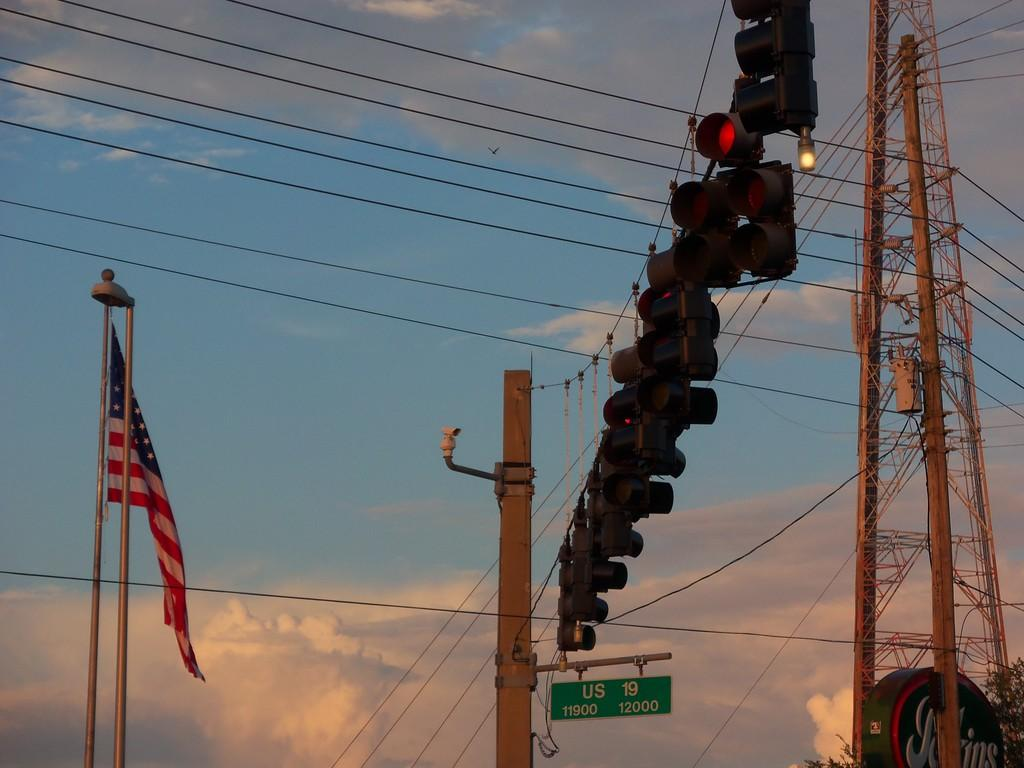Provide a one-sentence caption for the provided image. The sign reads US 19 which is the street below the lights. 